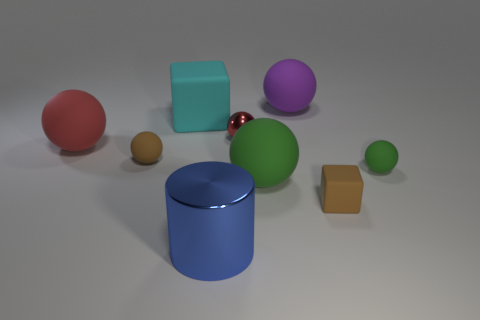If we imagine these objects are part of a game, which one would you choose to move first and why? If these objects were part of a game, I might choose to move the tiny brown ball first. Its smaller size makes it seem like a piece that could be easily maneuvered or perhaps it has a unique role due to its distinct size and color. It may also represent a pawn or a key element in strategic gameplay. 